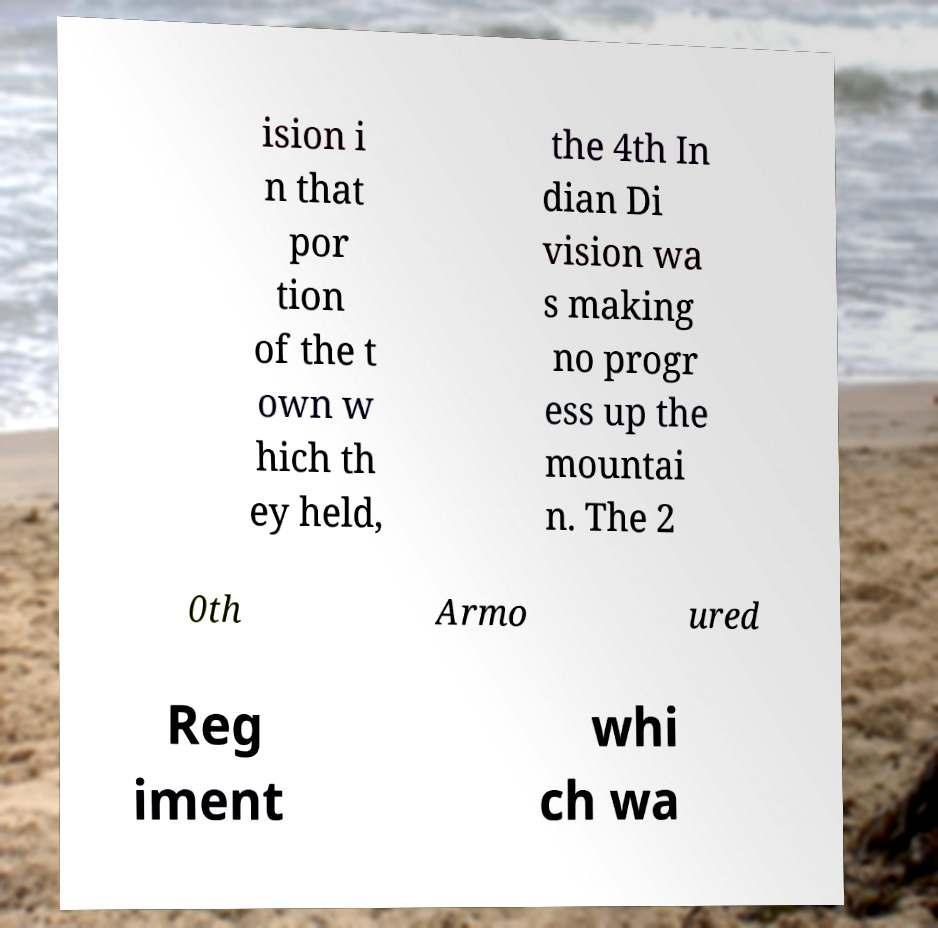Could you extract and type out the text from this image? ision i n that por tion of the t own w hich th ey held, the 4th In dian Di vision wa s making no progr ess up the mountai n. The 2 0th Armo ured Reg iment whi ch wa 